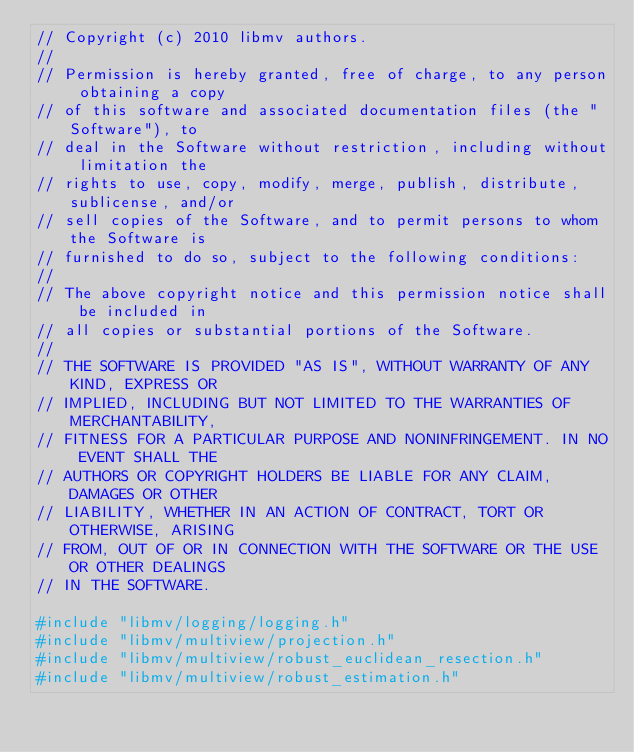<code> <loc_0><loc_0><loc_500><loc_500><_C++_>// Copyright (c) 2010 libmv authors.
//
// Permission is hereby granted, free of charge, to any person obtaining a copy
// of this software and associated documentation files (the "Software"), to
// deal in the Software without restriction, including without limitation the
// rights to use, copy, modify, merge, publish, distribute, sublicense, and/or
// sell copies of the Software, and to permit persons to whom the Software is
// furnished to do so, subject to the following conditions:
//
// The above copyright notice and this permission notice shall be included in
// all copies or substantial portions of the Software.
//
// THE SOFTWARE IS PROVIDED "AS IS", WITHOUT WARRANTY OF ANY KIND, EXPRESS OR
// IMPLIED, INCLUDING BUT NOT LIMITED TO THE WARRANTIES OF MERCHANTABILITY,
// FITNESS FOR A PARTICULAR PURPOSE AND NONINFRINGEMENT. IN NO EVENT SHALL THE
// AUTHORS OR COPYRIGHT HOLDERS BE LIABLE FOR ANY CLAIM, DAMAGES OR OTHER
// LIABILITY, WHETHER IN AN ACTION OF CONTRACT, TORT OR OTHERWISE, ARISING
// FROM, OUT OF OR IN CONNECTION WITH THE SOFTWARE OR THE USE OR OTHER DEALINGS
// IN THE SOFTWARE.

#include "libmv/logging/logging.h"
#include "libmv/multiview/projection.h"
#include "libmv/multiview/robust_euclidean_resection.h"
#include "libmv/multiview/robust_estimation.h"</code> 